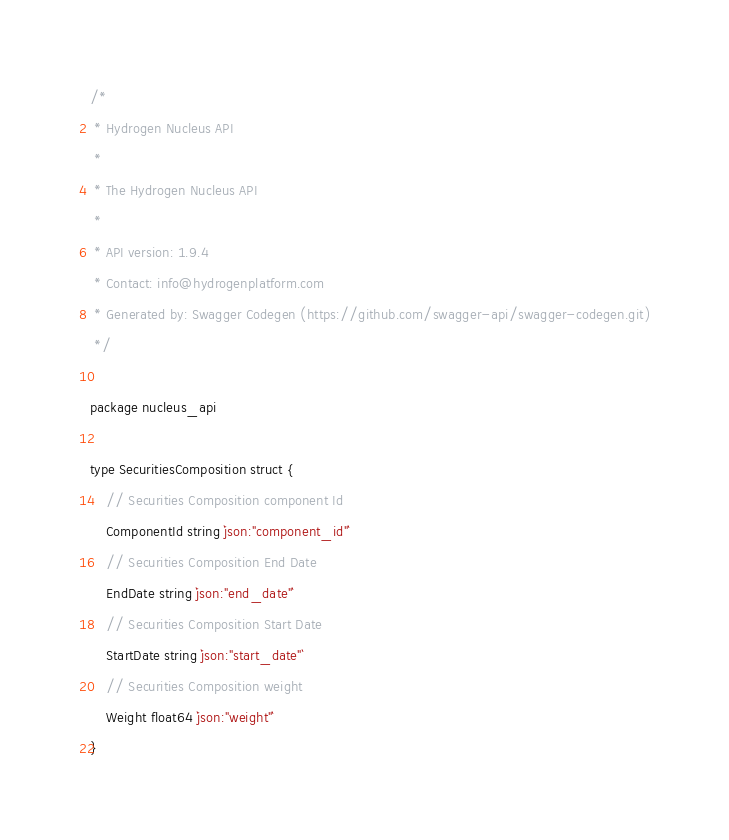Convert code to text. <code><loc_0><loc_0><loc_500><loc_500><_Go_>/*
 * Hydrogen Nucleus API
 *
 * The Hydrogen Nucleus API
 *
 * API version: 1.9.4
 * Contact: info@hydrogenplatform.com
 * Generated by: Swagger Codegen (https://github.com/swagger-api/swagger-codegen.git)
 */

package nucleus_api

type SecuritiesComposition struct {
	// Securities Composition component Id
	ComponentId string `json:"component_id"`
	// Securities Composition End Date
	EndDate string `json:"end_date"`
	// Securities Composition Start Date
	StartDate string `json:"start_date"`
	// Securities Composition weight
	Weight float64 `json:"weight"`
}
</code> 